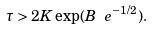Convert formula to latex. <formula><loc_0><loc_0><loc_500><loc_500>\tau > 2 K \exp ( B \ e ^ { - 1 / 2 } ) .</formula> 